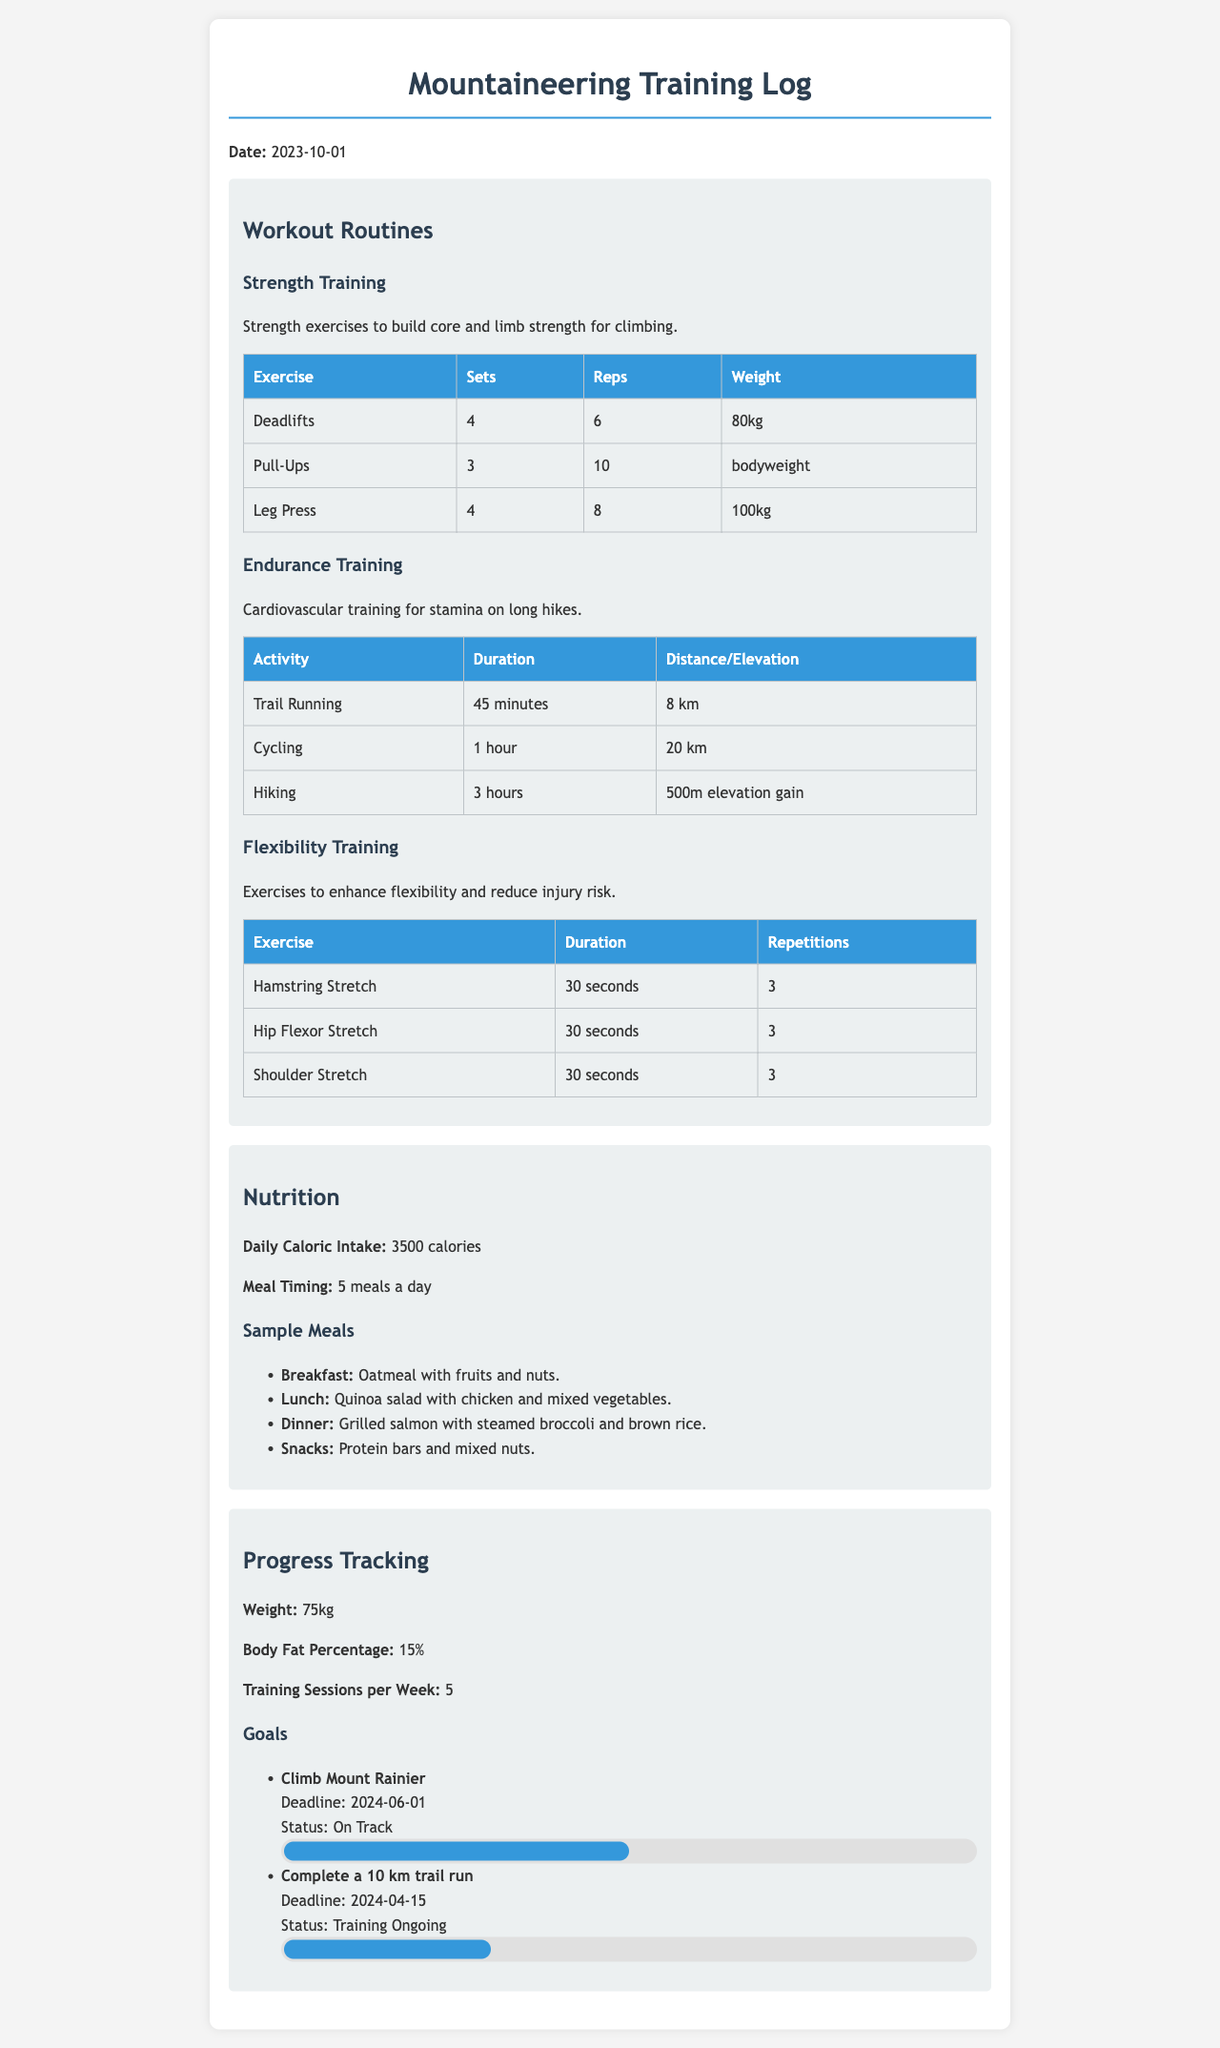what is the date of the training log? The date is clearly stated at the beginning of the document as 2023-10-01.
Answer: 2023-10-01 how many sets are performed for Deadlifts? The workout routines section specifies the number of sets for Deadlifts is listed in the Strength Training table.
Answer: 4 what is the daily caloric intake? The nutrition section provides the daily caloric intake as mentioned in the overview of the nutrition details.
Answer: 3500 calories what is the weight tracked in the progress section? The progress tracking section shows the current weight as outlined in the document.
Answer: 75kg what is the status of the goal to climb Mount Rainier? The status for this goal is mentioned in the goals list under progress tracking.
Answer: On Track what is the duration of the Trail Running activity? The duration can be found in the Endurance Training table which specifies the length of this activity.
Answer: 45 minutes how many training sessions are there per week? The number of training sessions per week is mentioned in the progress tracking section of the document.
Answer: 5 what is the deadline for completing a 10 km trail run? The specific deadline for this goal is detailed in the progress tracking section next to the goal statement.
Answer: 2024-04-15 how many meals are included in the meal timing? The document outlines the number of meals in the nutrition overview.
Answer: 5 meals a day 